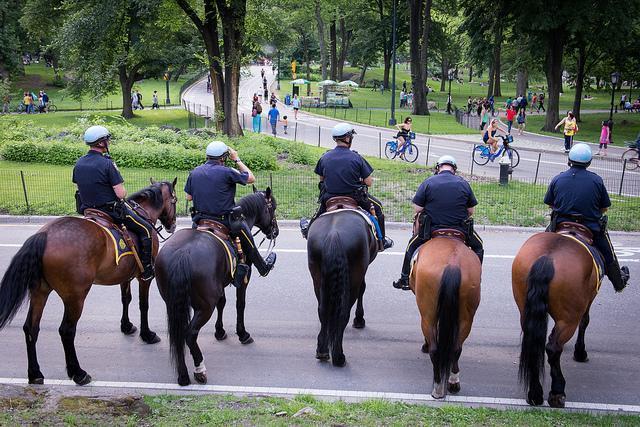How many horses can be seen?
Give a very brief answer. 5. How many people are there?
Give a very brief answer. 6. How many red cars are there?
Give a very brief answer. 0. 